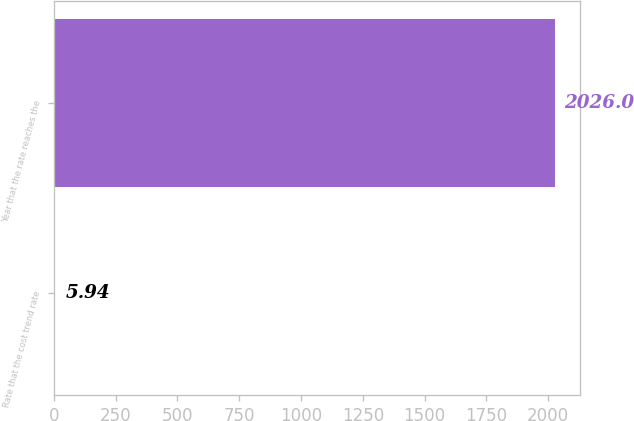<chart> <loc_0><loc_0><loc_500><loc_500><bar_chart><fcel>Rate that the cost trend rate<fcel>Year that the rate reaches the<nl><fcel>5.94<fcel>2026<nl></chart> 